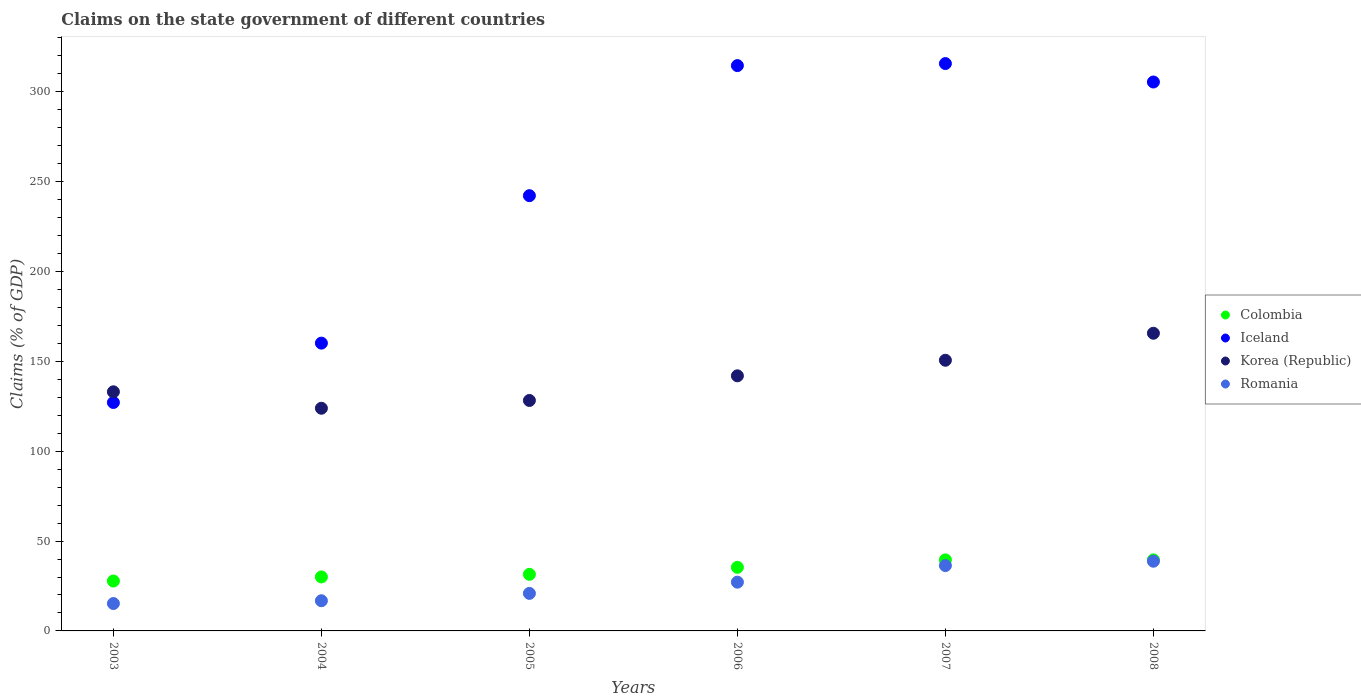Is the number of dotlines equal to the number of legend labels?
Offer a very short reply. Yes. What is the percentage of GDP claimed on the state government in Colombia in 2004?
Your answer should be compact. 30.04. Across all years, what is the maximum percentage of GDP claimed on the state government in Romania?
Make the answer very short. 38.78. Across all years, what is the minimum percentage of GDP claimed on the state government in Romania?
Offer a terse response. 15.24. What is the total percentage of GDP claimed on the state government in Colombia in the graph?
Give a very brief answer. 203.73. What is the difference between the percentage of GDP claimed on the state government in Colombia in 2004 and that in 2007?
Provide a succinct answer. -9.48. What is the difference between the percentage of GDP claimed on the state government in Romania in 2003 and the percentage of GDP claimed on the state government in Iceland in 2008?
Give a very brief answer. -290.18. What is the average percentage of GDP claimed on the state government in Korea (Republic) per year?
Your answer should be compact. 140.56. In the year 2006, what is the difference between the percentage of GDP claimed on the state government in Iceland and percentage of GDP claimed on the state government in Romania?
Your response must be concise. 287.42. What is the ratio of the percentage of GDP claimed on the state government in Iceland in 2004 to that in 2008?
Keep it short and to the point. 0.52. Is the percentage of GDP claimed on the state government in Iceland in 2005 less than that in 2008?
Keep it short and to the point. Yes. Is the difference between the percentage of GDP claimed on the state government in Iceland in 2004 and 2005 greater than the difference between the percentage of GDP claimed on the state government in Romania in 2004 and 2005?
Offer a terse response. No. What is the difference between the highest and the second highest percentage of GDP claimed on the state government in Romania?
Offer a terse response. 2.44. What is the difference between the highest and the lowest percentage of GDP claimed on the state government in Iceland?
Give a very brief answer. 188.58. Is it the case that in every year, the sum of the percentage of GDP claimed on the state government in Romania and percentage of GDP claimed on the state government in Iceland  is greater than the sum of percentage of GDP claimed on the state government in Korea (Republic) and percentage of GDP claimed on the state government in Colombia?
Your response must be concise. Yes. Is it the case that in every year, the sum of the percentage of GDP claimed on the state government in Colombia and percentage of GDP claimed on the state government in Romania  is greater than the percentage of GDP claimed on the state government in Korea (Republic)?
Ensure brevity in your answer.  No. Does the percentage of GDP claimed on the state government in Colombia monotonically increase over the years?
Your response must be concise. Yes. Is the percentage of GDP claimed on the state government in Korea (Republic) strictly less than the percentage of GDP claimed on the state government in Iceland over the years?
Make the answer very short. No. How many years are there in the graph?
Offer a very short reply. 6. Does the graph contain any zero values?
Give a very brief answer. No. Where does the legend appear in the graph?
Your answer should be very brief. Center right. How are the legend labels stacked?
Provide a succinct answer. Vertical. What is the title of the graph?
Offer a very short reply. Claims on the state government of different countries. Does "Kuwait" appear as one of the legend labels in the graph?
Offer a very short reply. No. What is the label or title of the Y-axis?
Your answer should be very brief. Claims (% of GDP). What is the Claims (% of GDP) of Colombia in 2003?
Provide a short and direct response. 27.76. What is the Claims (% of GDP) of Iceland in 2003?
Your response must be concise. 127.1. What is the Claims (% of GDP) in Korea (Republic) in 2003?
Provide a succinct answer. 133.05. What is the Claims (% of GDP) in Romania in 2003?
Give a very brief answer. 15.24. What is the Claims (% of GDP) of Colombia in 2004?
Ensure brevity in your answer.  30.04. What is the Claims (% of GDP) of Iceland in 2004?
Offer a terse response. 160.13. What is the Claims (% of GDP) in Korea (Republic) in 2004?
Ensure brevity in your answer.  123.89. What is the Claims (% of GDP) of Romania in 2004?
Your response must be concise. 16.79. What is the Claims (% of GDP) of Colombia in 2005?
Keep it short and to the point. 31.48. What is the Claims (% of GDP) of Iceland in 2005?
Offer a very short reply. 242.18. What is the Claims (% of GDP) of Korea (Republic) in 2005?
Your answer should be compact. 128.22. What is the Claims (% of GDP) of Romania in 2005?
Offer a terse response. 20.89. What is the Claims (% of GDP) of Colombia in 2006?
Give a very brief answer. 35.38. What is the Claims (% of GDP) in Iceland in 2006?
Ensure brevity in your answer.  314.55. What is the Claims (% of GDP) of Korea (Republic) in 2006?
Ensure brevity in your answer.  141.94. What is the Claims (% of GDP) in Romania in 2006?
Your answer should be very brief. 27.13. What is the Claims (% of GDP) in Colombia in 2007?
Make the answer very short. 39.53. What is the Claims (% of GDP) of Iceland in 2007?
Your answer should be very brief. 315.68. What is the Claims (% of GDP) of Korea (Republic) in 2007?
Your answer should be very brief. 150.6. What is the Claims (% of GDP) of Romania in 2007?
Ensure brevity in your answer.  36.35. What is the Claims (% of GDP) of Colombia in 2008?
Your response must be concise. 39.53. What is the Claims (% of GDP) of Iceland in 2008?
Offer a very short reply. 305.42. What is the Claims (% of GDP) in Korea (Republic) in 2008?
Provide a succinct answer. 165.63. What is the Claims (% of GDP) in Romania in 2008?
Give a very brief answer. 38.78. Across all years, what is the maximum Claims (% of GDP) of Colombia?
Provide a succinct answer. 39.53. Across all years, what is the maximum Claims (% of GDP) in Iceland?
Offer a very short reply. 315.68. Across all years, what is the maximum Claims (% of GDP) of Korea (Republic)?
Give a very brief answer. 165.63. Across all years, what is the maximum Claims (% of GDP) of Romania?
Keep it short and to the point. 38.78. Across all years, what is the minimum Claims (% of GDP) of Colombia?
Your answer should be very brief. 27.76. Across all years, what is the minimum Claims (% of GDP) in Iceland?
Keep it short and to the point. 127.1. Across all years, what is the minimum Claims (% of GDP) in Korea (Republic)?
Provide a succinct answer. 123.89. Across all years, what is the minimum Claims (% of GDP) in Romania?
Offer a terse response. 15.24. What is the total Claims (% of GDP) of Colombia in the graph?
Keep it short and to the point. 203.73. What is the total Claims (% of GDP) of Iceland in the graph?
Keep it short and to the point. 1465.05. What is the total Claims (% of GDP) in Korea (Republic) in the graph?
Provide a succinct answer. 843.34. What is the total Claims (% of GDP) in Romania in the graph?
Make the answer very short. 155.18. What is the difference between the Claims (% of GDP) in Colombia in 2003 and that in 2004?
Ensure brevity in your answer.  -2.28. What is the difference between the Claims (% of GDP) in Iceland in 2003 and that in 2004?
Your answer should be compact. -33.03. What is the difference between the Claims (% of GDP) in Korea (Republic) in 2003 and that in 2004?
Your answer should be very brief. 9.15. What is the difference between the Claims (% of GDP) in Romania in 2003 and that in 2004?
Offer a terse response. -1.55. What is the difference between the Claims (% of GDP) in Colombia in 2003 and that in 2005?
Offer a very short reply. -3.72. What is the difference between the Claims (% of GDP) in Iceland in 2003 and that in 2005?
Provide a succinct answer. -115.08. What is the difference between the Claims (% of GDP) in Korea (Republic) in 2003 and that in 2005?
Give a very brief answer. 4.82. What is the difference between the Claims (% of GDP) of Romania in 2003 and that in 2005?
Your answer should be very brief. -5.65. What is the difference between the Claims (% of GDP) in Colombia in 2003 and that in 2006?
Ensure brevity in your answer.  -7.62. What is the difference between the Claims (% of GDP) of Iceland in 2003 and that in 2006?
Give a very brief answer. -187.45. What is the difference between the Claims (% of GDP) of Korea (Republic) in 2003 and that in 2006?
Provide a short and direct response. -8.89. What is the difference between the Claims (% of GDP) of Romania in 2003 and that in 2006?
Your response must be concise. -11.89. What is the difference between the Claims (% of GDP) of Colombia in 2003 and that in 2007?
Your response must be concise. -11.76. What is the difference between the Claims (% of GDP) of Iceland in 2003 and that in 2007?
Provide a short and direct response. -188.58. What is the difference between the Claims (% of GDP) of Korea (Republic) in 2003 and that in 2007?
Offer a very short reply. -17.55. What is the difference between the Claims (% of GDP) of Romania in 2003 and that in 2007?
Ensure brevity in your answer.  -21.11. What is the difference between the Claims (% of GDP) in Colombia in 2003 and that in 2008?
Your answer should be compact. -11.77. What is the difference between the Claims (% of GDP) of Iceland in 2003 and that in 2008?
Offer a very short reply. -178.32. What is the difference between the Claims (% of GDP) of Korea (Republic) in 2003 and that in 2008?
Keep it short and to the point. -32.58. What is the difference between the Claims (% of GDP) of Romania in 2003 and that in 2008?
Keep it short and to the point. -23.55. What is the difference between the Claims (% of GDP) in Colombia in 2004 and that in 2005?
Provide a short and direct response. -1.44. What is the difference between the Claims (% of GDP) of Iceland in 2004 and that in 2005?
Provide a short and direct response. -82.05. What is the difference between the Claims (% of GDP) in Korea (Republic) in 2004 and that in 2005?
Your answer should be very brief. -4.33. What is the difference between the Claims (% of GDP) of Romania in 2004 and that in 2005?
Your answer should be very brief. -4.1. What is the difference between the Claims (% of GDP) in Colombia in 2004 and that in 2006?
Offer a very short reply. -5.34. What is the difference between the Claims (% of GDP) in Iceland in 2004 and that in 2006?
Offer a terse response. -154.42. What is the difference between the Claims (% of GDP) of Korea (Republic) in 2004 and that in 2006?
Your answer should be compact. -18.05. What is the difference between the Claims (% of GDP) of Romania in 2004 and that in 2006?
Make the answer very short. -10.34. What is the difference between the Claims (% of GDP) in Colombia in 2004 and that in 2007?
Make the answer very short. -9.48. What is the difference between the Claims (% of GDP) in Iceland in 2004 and that in 2007?
Give a very brief answer. -155.55. What is the difference between the Claims (% of GDP) in Korea (Republic) in 2004 and that in 2007?
Your answer should be very brief. -26.71. What is the difference between the Claims (% of GDP) of Romania in 2004 and that in 2007?
Ensure brevity in your answer.  -19.56. What is the difference between the Claims (% of GDP) in Colombia in 2004 and that in 2008?
Ensure brevity in your answer.  -9.49. What is the difference between the Claims (% of GDP) in Iceland in 2004 and that in 2008?
Provide a succinct answer. -145.29. What is the difference between the Claims (% of GDP) of Korea (Republic) in 2004 and that in 2008?
Provide a succinct answer. -41.73. What is the difference between the Claims (% of GDP) of Romania in 2004 and that in 2008?
Your answer should be very brief. -22. What is the difference between the Claims (% of GDP) of Colombia in 2005 and that in 2006?
Provide a succinct answer. -3.9. What is the difference between the Claims (% of GDP) of Iceland in 2005 and that in 2006?
Your answer should be compact. -72.37. What is the difference between the Claims (% of GDP) in Korea (Republic) in 2005 and that in 2006?
Provide a short and direct response. -13.72. What is the difference between the Claims (% of GDP) in Romania in 2005 and that in 2006?
Give a very brief answer. -6.25. What is the difference between the Claims (% of GDP) in Colombia in 2005 and that in 2007?
Your response must be concise. -8.04. What is the difference between the Claims (% of GDP) in Iceland in 2005 and that in 2007?
Your answer should be very brief. -73.5. What is the difference between the Claims (% of GDP) in Korea (Republic) in 2005 and that in 2007?
Ensure brevity in your answer.  -22.38. What is the difference between the Claims (% of GDP) of Romania in 2005 and that in 2007?
Provide a short and direct response. -15.46. What is the difference between the Claims (% of GDP) in Colombia in 2005 and that in 2008?
Offer a terse response. -8.05. What is the difference between the Claims (% of GDP) of Iceland in 2005 and that in 2008?
Make the answer very short. -63.24. What is the difference between the Claims (% of GDP) of Korea (Republic) in 2005 and that in 2008?
Ensure brevity in your answer.  -37.4. What is the difference between the Claims (% of GDP) in Romania in 2005 and that in 2008?
Provide a short and direct response. -17.9. What is the difference between the Claims (% of GDP) of Colombia in 2006 and that in 2007?
Keep it short and to the point. -4.14. What is the difference between the Claims (% of GDP) of Iceland in 2006 and that in 2007?
Give a very brief answer. -1.13. What is the difference between the Claims (% of GDP) in Korea (Republic) in 2006 and that in 2007?
Keep it short and to the point. -8.66. What is the difference between the Claims (% of GDP) of Romania in 2006 and that in 2007?
Provide a short and direct response. -9.21. What is the difference between the Claims (% of GDP) of Colombia in 2006 and that in 2008?
Your answer should be compact. -4.15. What is the difference between the Claims (% of GDP) of Iceland in 2006 and that in 2008?
Keep it short and to the point. 9.13. What is the difference between the Claims (% of GDP) of Korea (Republic) in 2006 and that in 2008?
Provide a succinct answer. -23.69. What is the difference between the Claims (% of GDP) of Romania in 2006 and that in 2008?
Keep it short and to the point. -11.65. What is the difference between the Claims (% of GDP) in Colombia in 2007 and that in 2008?
Ensure brevity in your answer.  -0.01. What is the difference between the Claims (% of GDP) in Iceland in 2007 and that in 2008?
Your answer should be compact. 10.26. What is the difference between the Claims (% of GDP) of Korea (Republic) in 2007 and that in 2008?
Provide a short and direct response. -15.03. What is the difference between the Claims (% of GDP) in Romania in 2007 and that in 2008?
Your response must be concise. -2.44. What is the difference between the Claims (% of GDP) in Colombia in 2003 and the Claims (% of GDP) in Iceland in 2004?
Offer a terse response. -132.37. What is the difference between the Claims (% of GDP) in Colombia in 2003 and the Claims (% of GDP) in Korea (Republic) in 2004?
Keep it short and to the point. -96.13. What is the difference between the Claims (% of GDP) in Colombia in 2003 and the Claims (% of GDP) in Romania in 2004?
Your answer should be compact. 10.97. What is the difference between the Claims (% of GDP) in Iceland in 2003 and the Claims (% of GDP) in Korea (Republic) in 2004?
Offer a terse response. 3.21. What is the difference between the Claims (% of GDP) in Iceland in 2003 and the Claims (% of GDP) in Romania in 2004?
Give a very brief answer. 110.31. What is the difference between the Claims (% of GDP) of Korea (Republic) in 2003 and the Claims (% of GDP) of Romania in 2004?
Your answer should be very brief. 116.26. What is the difference between the Claims (% of GDP) in Colombia in 2003 and the Claims (% of GDP) in Iceland in 2005?
Provide a short and direct response. -214.41. What is the difference between the Claims (% of GDP) in Colombia in 2003 and the Claims (% of GDP) in Korea (Republic) in 2005?
Offer a terse response. -100.46. What is the difference between the Claims (% of GDP) of Colombia in 2003 and the Claims (% of GDP) of Romania in 2005?
Keep it short and to the point. 6.88. What is the difference between the Claims (% of GDP) in Iceland in 2003 and the Claims (% of GDP) in Korea (Republic) in 2005?
Give a very brief answer. -1.12. What is the difference between the Claims (% of GDP) in Iceland in 2003 and the Claims (% of GDP) in Romania in 2005?
Your response must be concise. 106.21. What is the difference between the Claims (% of GDP) in Korea (Republic) in 2003 and the Claims (% of GDP) in Romania in 2005?
Keep it short and to the point. 112.16. What is the difference between the Claims (% of GDP) of Colombia in 2003 and the Claims (% of GDP) of Iceland in 2006?
Provide a succinct answer. -286.78. What is the difference between the Claims (% of GDP) of Colombia in 2003 and the Claims (% of GDP) of Korea (Republic) in 2006?
Give a very brief answer. -114.18. What is the difference between the Claims (% of GDP) of Colombia in 2003 and the Claims (% of GDP) of Romania in 2006?
Ensure brevity in your answer.  0.63. What is the difference between the Claims (% of GDP) of Iceland in 2003 and the Claims (% of GDP) of Korea (Republic) in 2006?
Offer a terse response. -14.84. What is the difference between the Claims (% of GDP) of Iceland in 2003 and the Claims (% of GDP) of Romania in 2006?
Provide a succinct answer. 99.97. What is the difference between the Claims (% of GDP) in Korea (Republic) in 2003 and the Claims (% of GDP) in Romania in 2006?
Your answer should be compact. 105.92. What is the difference between the Claims (% of GDP) in Colombia in 2003 and the Claims (% of GDP) in Iceland in 2007?
Keep it short and to the point. -287.91. What is the difference between the Claims (% of GDP) in Colombia in 2003 and the Claims (% of GDP) in Korea (Republic) in 2007?
Give a very brief answer. -122.84. What is the difference between the Claims (% of GDP) of Colombia in 2003 and the Claims (% of GDP) of Romania in 2007?
Give a very brief answer. -8.58. What is the difference between the Claims (% of GDP) in Iceland in 2003 and the Claims (% of GDP) in Korea (Republic) in 2007?
Your answer should be very brief. -23.5. What is the difference between the Claims (% of GDP) in Iceland in 2003 and the Claims (% of GDP) in Romania in 2007?
Your response must be concise. 90.75. What is the difference between the Claims (% of GDP) of Korea (Republic) in 2003 and the Claims (% of GDP) of Romania in 2007?
Ensure brevity in your answer.  96.7. What is the difference between the Claims (% of GDP) of Colombia in 2003 and the Claims (% of GDP) of Iceland in 2008?
Provide a short and direct response. -277.66. What is the difference between the Claims (% of GDP) in Colombia in 2003 and the Claims (% of GDP) in Korea (Republic) in 2008?
Keep it short and to the point. -137.86. What is the difference between the Claims (% of GDP) of Colombia in 2003 and the Claims (% of GDP) of Romania in 2008?
Your answer should be very brief. -11.02. What is the difference between the Claims (% of GDP) in Iceland in 2003 and the Claims (% of GDP) in Korea (Republic) in 2008?
Offer a terse response. -38.53. What is the difference between the Claims (% of GDP) of Iceland in 2003 and the Claims (% of GDP) of Romania in 2008?
Your answer should be very brief. 88.32. What is the difference between the Claims (% of GDP) of Korea (Republic) in 2003 and the Claims (% of GDP) of Romania in 2008?
Your answer should be very brief. 94.26. What is the difference between the Claims (% of GDP) in Colombia in 2004 and the Claims (% of GDP) in Iceland in 2005?
Provide a short and direct response. -212.13. What is the difference between the Claims (% of GDP) in Colombia in 2004 and the Claims (% of GDP) in Korea (Republic) in 2005?
Your response must be concise. -98.18. What is the difference between the Claims (% of GDP) of Colombia in 2004 and the Claims (% of GDP) of Romania in 2005?
Offer a very short reply. 9.16. What is the difference between the Claims (% of GDP) of Iceland in 2004 and the Claims (% of GDP) of Korea (Republic) in 2005?
Offer a terse response. 31.9. What is the difference between the Claims (% of GDP) of Iceland in 2004 and the Claims (% of GDP) of Romania in 2005?
Ensure brevity in your answer.  139.24. What is the difference between the Claims (% of GDP) of Korea (Republic) in 2004 and the Claims (% of GDP) of Romania in 2005?
Ensure brevity in your answer.  103.01. What is the difference between the Claims (% of GDP) of Colombia in 2004 and the Claims (% of GDP) of Iceland in 2006?
Keep it short and to the point. -284.51. What is the difference between the Claims (% of GDP) in Colombia in 2004 and the Claims (% of GDP) in Korea (Republic) in 2006?
Your response must be concise. -111.9. What is the difference between the Claims (% of GDP) in Colombia in 2004 and the Claims (% of GDP) in Romania in 2006?
Make the answer very short. 2.91. What is the difference between the Claims (% of GDP) of Iceland in 2004 and the Claims (% of GDP) of Korea (Republic) in 2006?
Your answer should be very brief. 18.19. What is the difference between the Claims (% of GDP) in Iceland in 2004 and the Claims (% of GDP) in Romania in 2006?
Offer a terse response. 133. What is the difference between the Claims (% of GDP) in Korea (Republic) in 2004 and the Claims (% of GDP) in Romania in 2006?
Your answer should be compact. 96.76. What is the difference between the Claims (% of GDP) in Colombia in 2004 and the Claims (% of GDP) in Iceland in 2007?
Your response must be concise. -285.63. What is the difference between the Claims (% of GDP) of Colombia in 2004 and the Claims (% of GDP) of Korea (Republic) in 2007?
Provide a short and direct response. -120.56. What is the difference between the Claims (% of GDP) of Colombia in 2004 and the Claims (% of GDP) of Romania in 2007?
Provide a short and direct response. -6.3. What is the difference between the Claims (% of GDP) of Iceland in 2004 and the Claims (% of GDP) of Korea (Republic) in 2007?
Your response must be concise. 9.53. What is the difference between the Claims (% of GDP) of Iceland in 2004 and the Claims (% of GDP) of Romania in 2007?
Offer a terse response. 123.78. What is the difference between the Claims (% of GDP) of Korea (Republic) in 2004 and the Claims (% of GDP) of Romania in 2007?
Your response must be concise. 87.55. What is the difference between the Claims (% of GDP) in Colombia in 2004 and the Claims (% of GDP) in Iceland in 2008?
Give a very brief answer. -275.38. What is the difference between the Claims (% of GDP) of Colombia in 2004 and the Claims (% of GDP) of Korea (Republic) in 2008?
Ensure brevity in your answer.  -135.58. What is the difference between the Claims (% of GDP) of Colombia in 2004 and the Claims (% of GDP) of Romania in 2008?
Make the answer very short. -8.74. What is the difference between the Claims (% of GDP) in Iceland in 2004 and the Claims (% of GDP) in Korea (Republic) in 2008?
Provide a succinct answer. -5.5. What is the difference between the Claims (% of GDP) of Iceland in 2004 and the Claims (% of GDP) of Romania in 2008?
Provide a short and direct response. 121.34. What is the difference between the Claims (% of GDP) in Korea (Republic) in 2004 and the Claims (% of GDP) in Romania in 2008?
Offer a terse response. 85.11. What is the difference between the Claims (% of GDP) in Colombia in 2005 and the Claims (% of GDP) in Iceland in 2006?
Your answer should be compact. -283.06. What is the difference between the Claims (% of GDP) of Colombia in 2005 and the Claims (% of GDP) of Korea (Republic) in 2006?
Offer a very short reply. -110.46. What is the difference between the Claims (% of GDP) in Colombia in 2005 and the Claims (% of GDP) in Romania in 2006?
Your answer should be compact. 4.35. What is the difference between the Claims (% of GDP) in Iceland in 2005 and the Claims (% of GDP) in Korea (Republic) in 2006?
Ensure brevity in your answer.  100.24. What is the difference between the Claims (% of GDP) in Iceland in 2005 and the Claims (% of GDP) in Romania in 2006?
Give a very brief answer. 215.04. What is the difference between the Claims (% of GDP) of Korea (Republic) in 2005 and the Claims (% of GDP) of Romania in 2006?
Make the answer very short. 101.09. What is the difference between the Claims (% of GDP) of Colombia in 2005 and the Claims (% of GDP) of Iceland in 2007?
Keep it short and to the point. -284.19. What is the difference between the Claims (% of GDP) in Colombia in 2005 and the Claims (% of GDP) in Korea (Republic) in 2007?
Your answer should be compact. -119.12. What is the difference between the Claims (% of GDP) of Colombia in 2005 and the Claims (% of GDP) of Romania in 2007?
Keep it short and to the point. -4.86. What is the difference between the Claims (% of GDP) in Iceland in 2005 and the Claims (% of GDP) in Korea (Republic) in 2007?
Your response must be concise. 91.58. What is the difference between the Claims (% of GDP) of Iceland in 2005 and the Claims (% of GDP) of Romania in 2007?
Your answer should be compact. 205.83. What is the difference between the Claims (% of GDP) in Korea (Republic) in 2005 and the Claims (% of GDP) in Romania in 2007?
Offer a terse response. 91.88. What is the difference between the Claims (% of GDP) of Colombia in 2005 and the Claims (% of GDP) of Iceland in 2008?
Your answer should be compact. -273.94. What is the difference between the Claims (% of GDP) of Colombia in 2005 and the Claims (% of GDP) of Korea (Republic) in 2008?
Ensure brevity in your answer.  -134.14. What is the difference between the Claims (% of GDP) in Colombia in 2005 and the Claims (% of GDP) in Romania in 2008?
Provide a succinct answer. -7.3. What is the difference between the Claims (% of GDP) in Iceland in 2005 and the Claims (% of GDP) in Korea (Republic) in 2008?
Your answer should be compact. 76.55. What is the difference between the Claims (% of GDP) in Iceland in 2005 and the Claims (% of GDP) in Romania in 2008?
Your answer should be compact. 203.39. What is the difference between the Claims (% of GDP) in Korea (Republic) in 2005 and the Claims (% of GDP) in Romania in 2008?
Your answer should be very brief. 89.44. What is the difference between the Claims (% of GDP) in Colombia in 2006 and the Claims (% of GDP) in Iceland in 2007?
Offer a very short reply. -280.29. What is the difference between the Claims (% of GDP) of Colombia in 2006 and the Claims (% of GDP) of Korea (Republic) in 2007?
Give a very brief answer. -115.21. What is the difference between the Claims (% of GDP) of Colombia in 2006 and the Claims (% of GDP) of Romania in 2007?
Ensure brevity in your answer.  -0.96. What is the difference between the Claims (% of GDP) in Iceland in 2006 and the Claims (% of GDP) in Korea (Republic) in 2007?
Provide a short and direct response. 163.95. What is the difference between the Claims (% of GDP) of Iceland in 2006 and the Claims (% of GDP) of Romania in 2007?
Your answer should be compact. 278.2. What is the difference between the Claims (% of GDP) of Korea (Republic) in 2006 and the Claims (% of GDP) of Romania in 2007?
Offer a terse response. 105.59. What is the difference between the Claims (% of GDP) in Colombia in 2006 and the Claims (% of GDP) in Iceland in 2008?
Offer a very short reply. -270.03. What is the difference between the Claims (% of GDP) of Colombia in 2006 and the Claims (% of GDP) of Korea (Republic) in 2008?
Provide a succinct answer. -130.24. What is the difference between the Claims (% of GDP) of Colombia in 2006 and the Claims (% of GDP) of Romania in 2008?
Your answer should be compact. -3.4. What is the difference between the Claims (% of GDP) in Iceland in 2006 and the Claims (% of GDP) in Korea (Republic) in 2008?
Provide a short and direct response. 148.92. What is the difference between the Claims (% of GDP) in Iceland in 2006 and the Claims (% of GDP) in Romania in 2008?
Make the answer very short. 275.76. What is the difference between the Claims (% of GDP) in Korea (Republic) in 2006 and the Claims (% of GDP) in Romania in 2008?
Offer a terse response. 103.16. What is the difference between the Claims (% of GDP) of Colombia in 2007 and the Claims (% of GDP) of Iceland in 2008?
Keep it short and to the point. -265.89. What is the difference between the Claims (% of GDP) in Colombia in 2007 and the Claims (% of GDP) in Korea (Republic) in 2008?
Your answer should be very brief. -126.1. What is the difference between the Claims (% of GDP) in Colombia in 2007 and the Claims (% of GDP) in Romania in 2008?
Your answer should be very brief. 0.74. What is the difference between the Claims (% of GDP) in Iceland in 2007 and the Claims (% of GDP) in Korea (Republic) in 2008?
Offer a terse response. 150.05. What is the difference between the Claims (% of GDP) in Iceland in 2007 and the Claims (% of GDP) in Romania in 2008?
Ensure brevity in your answer.  276.89. What is the difference between the Claims (% of GDP) in Korea (Republic) in 2007 and the Claims (% of GDP) in Romania in 2008?
Offer a very short reply. 111.82. What is the average Claims (% of GDP) of Colombia per year?
Give a very brief answer. 33.96. What is the average Claims (% of GDP) in Iceland per year?
Make the answer very short. 244.17. What is the average Claims (% of GDP) in Korea (Republic) per year?
Your answer should be very brief. 140.56. What is the average Claims (% of GDP) in Romania per year?
Provide a short and direct response. 25.86. In the year 2003, what is the difference between the Claims (% of GDP) in Colombia and Claims (% of GDP) in Iceland?
Keep it short and to the point. -99.34. In the year 2003, what is the difference between the Claims (% of GDP) in Colombia and Claims (% of GDP) in Korea (Republic)?
Offer a very short reply. -105.28. In the year 2003, what is the difference between the Claims (% of GDP) in Colombia and Claims (% of GDP) in Romania?
Keep it short and to the point. 12.53. In the year 2003, what is the difference between the Claims (% of GDP) of Iceland and Claims (% of GDP) of Korea (Republic)?
Ensure brevity in your answer.  -5.95. In the year 2003, what is the difference between the Claims (% of GDP) of Iceland and Claims (% of GDP) of Romania?
Give a very brief answer. 111.86. In the year 2003, what is the difference between the Claims (% of GDP) in Korea (Republic) and Claims (% of GDP) in Romania?
Offer a terse response. 117.81. In the year 2004, what is the difference between the Claims (% of GDP) in Colombia and Claims (% of GDP) in Iceland?
Ensure brevity in your answer.  -130.09. In the year 2004, what is the difference between the Claims (% of GDP) in Colombia and Claims (% of GDP) in Korea (Republic)?
Your answer should be very brief. -93.85. In the year 2004, what is the difference between the Claims (% of GDP) of Colombia and Claims (% of GDP) of Romania?
Your answer should be very brief. 13.25. In the year 2004, what is the difference between the Claims (% of GDP) of Iceland and Claims (% of GDP) of Korea (Republic)?
Ensure brevity in your answer.  36.23. In the year 2004, what is the difference between the Claims (% of GDP) in Iceland and Claims (% of GDP) in Romania?
Make the answer very short. 143.34. In the year 2004, what is the difference between the Claims (% of GDP) of Korea (Republic) and Claims (% of GDP) of Romania?
Keep it short and to the point. 107.11. In the year 2005, what is the difference between the Claims (% of GDP) of Colombia and Claims (% of GDP) of Iceland?
Your answer should be compact. -210.69. In the year 2005, what is the difference between the Claims (% of GDP) in Colombia and Claims (% of GDP) in Korea (Republic)?
Your response must be concise. -96.74. In the year 2005, what is the difference between the Claims (% of GDP) in Colombia and Claims (% of GDP) in Romania?
Your response must be concise. 10.6. In the year 2005, what is the difference between the Claims (% of GDP) in Iceland and Claims (% of GDP) in Korea (Republic)?
Ensure brevity in your answer.  113.95. In the year 2005, what is the difference between the Claims (% of GDP) in Iceland and Claims (% of GDP) in Romania?
Give a very brief answer. 221.29. In the year 2005, what is the difference between the Claims (% of GDP) of Korea (Republic) and Claims (% of GDP) of Romania?
Keep it short and to the point. 107.34. In the year 2006, what is the difference between the Claims (% of GDP) of Colombia and Claims (% of GDP) of Iceland?
Give a very brief answer. -279.16. In the year 2006, what is the difference between the Claims (% of GDP) in Colombia and Claims (% of GDP) in Korea (Republic)?
Provide a short and direct response. -106.56. In the year 2006, what is the difference between the Claims (% of GDP) in Colombia and Claims (% of GDP) in Romania?
Provide a short and direct response. 8.25. In the year 2006, what is the difference between the Claims (% of GDP) in Iceland and Claims (% of GDP) in Korea (Republic)?
Keep it short and to the point. 172.61. In the year 2006, what is the difference between the Claims (% of GDP) of Iceland and Claims (% of GDP) of Romania?
Make the answer very short. 287.42. In the year 2006, what is the difference between the Claims (% of GDP) of Korea (Republic) and Claims (% of GDP) of Romania?
Ensure brevity in your answer.  114.81. In the year 2007, what is the difference between the Claims (% of GDP) of Colombia and Claims (% of GDP) of Iceland?
Provide a succinct answer. -276.15. In the year 2007, what is the difference between the Claims (% of GDP) of Colombia and Claims (% of GDP) of Korea (Republic)?
Make the answer very short. -111.07. In the year 2007, what is the difference between the Claims (% of GDP) of Colombia and Claims (% of GDP) of Romania?
Keep it short and to the point. 3.18. In the year 2007, what is the difference between the Claims (% of GDP) of Iceland and Claims (% of GDP) of Korea (Republic)?
Your answer should be compact. 165.08. In the year 2007, what is the difference between the Claims (% of GDP) in Iceland and Claims (% of GDP) in Romania?
Give a very brief answer. 279.33. In the year 2007, what is the difference between the Claims (% of GDP) of Korea (Republic) and Claims (% of GDP) of Romania?
Your answer should be very brief. 114.25. In the year 2008, what is the difference between the Claims (% of GDP) of Colombia and Claims (% of GDP) of Iceland?
Your answer should be compact. -265.89. In the year 2008, what is the difference between the Claims (% of GDP) of Colombia and Claims (% of GDP) of Korea (Republic)?
Keep it short and to the point. -126.1. In the year 2008, what is the difference between the Claims (% of GDP) of Colombia and Claims (% of GDP) of Romania?
Your answer should be very brief. 0.75. In the year 2008, what is the difference between the Claims (% of GDP) of Iceland and Claims (% of GDP) of Korea (Republic)?
Your response must be concise. 139.79. In the year 2008, what is the difference between the Claims (% of GDP) of Iceland and Claims (% of GDP) of Romania?
Your answer should be compact. 266.63. In the year 2008, what is the difference between the Claims (% of GDP) in Korea (Republic) and Claims (% of GDP) in Romania?
Give a very brief answer. 126.84. What is the ratio of the Claims (% of GDP) of Colombia in 2003 to that in 2004?
Provide a short and direct response. 0.92. What is the ratio of the Claims (% of GDP) in Iceland in 2003 to that in 2004?
Provide a short and direct response. 0.79. What is the ratio of the Claims (% of GDP) in Korea (Republic) in 2003 to that in 2004?
Ensure brevity in your answer.  1.07. What is the ratio of the Claims (% of GDP) of Romania in 2003 to that in 2004?
Offer a very short reply. 0.91. What is the ratio of the Claims (% of GDP) of Colombia in 2003 to that in 2005?
Your response must be concise. 0.88. What is the ratio of the Claims (% of GDP) of Iceland in 2003 to that in 2005?
Give a very brief answer. 0.52. What is the ratio of the Claims (% of GDP) in Korea (Republic) in 2003 to that in 2005?
Your answer should be compact. 1.04. What is the ratio of the Claims (% of GDP) of Romania in 2003 to that in 2005?
Ensure brevity in your answer.  0.73. What is the ratio of the Claims (% of GDP) in Colombia in 2003 to that in 2006?
Offer a terse response. 0.78. What is the ratio of the Claims (% of GDP) in Iceland in 2003 to that in 2006?
Offer a very short reply. 0.4. What is the ratio of the Claims (% of GDP) of Korea (Republic) in 2003 to that in 2006?
Provide a succinct answer. 0.94. What is the ratio of the Claims (% of GDP) of Romania in 2003 to that in 2006?
Ensure brevity in your answer.  0.56. What is the ratio of the Claims (% of GDP) of Colombia in 2003 to that in 2007?
Make the answer very short. 0.7. What is the ratio of the Claims (% of GDP) in Iceland in 2003 to that in 2007?
Your answer should be very brief. 0.4. What is the ratio of the Claims (% of GDP) of Korea (Republic) in 2003 to that in 2007?
Your answer should be compact. 0.88. What is the ratio of the Claims (% of GDP) in Romania in 2003 to that in 2007?
Make the answer very short. 0.42. What is the ratio of the Claims (% of GDP) in Colombia in 2003 to that in 2008?
Offer a terse response. 0.7. What is the ratio of the Claims (% of GDP) in Iceland in 2003 to that in 2008?
Your answer should be very brief. 0.42. What is the ratio of the Claims (% of GDP) of Korea (Republic) in 2003 to that in 2008?
Offer a terse response. 0.8. What is the ratio of the Claims (% of GDP) of Romania in 2003 to that in 2008?
Your answer should be very brief. 0.39. What is the ratio of the Claims (% of GDP) of Colombia in 2004 to that in 2005?
Offer a very short reply. 0.95. What is the ratio of the Claims (% of GDP) of Iceland in 2004 to that in 2005?
Provide a short and direct response. 0.66. What is the ratio of the Claims (% of GDP) of Korea (Republic) in 2004 to that in 2005?
Give a very brief answer. 0.97. What is the ratio of the Claims (% of GDP) in Romania in 2004 to that in 2005?
Give a very brief answer. 0.8. What is the ratio of the Claims (% of GDP) in Colombia in 2004 to that in 2006?
Provide a succinct answer. 0.85. What is the ratio of the Claims (% of GDP) of Iceland in 2004 to that in 2006?
Ensure brevity in your answer.  0.51. What is the ratio of the Claims (% of GDP) in Korea (Republic) in 2004 to that in 2006?
Give a very brief answer. 0.87. What is the ratio of the Claims (% of GDP) of Romania in 2004 to that in 2006?
Make the answer very short. 0.62. What is the ratio of the Claims (% of GDP) in Colombia in 2004 to that in 2007?
Provide a short and direct response. 0.76. What is the ratio of the Claims (% of GDP) of Iceland in 2004 to that in 2007?
Make the answer very short. 0.51. What is the ratio of the Claims (% of GDP) in Korea (Republic) in 2004 to that in 2007?
Your response must be concise. 0.82. What is the ratio of the Claims (% of GDP) in Romania in 2004 to that in 2007?
Offer a very short reply. 0.46. What is the ratio of the Claims (% of GDP) in Colombia in 2004 to that in 2008?
Make the answer very short. 0.76. What is the ratio of the Claims (% of GDP) in Iceland in 2004 to that in 2008?
Offer a very short reply. 0.52. What is the ratio of the Claims (% of GDP) in Korea (Republic) in 2004 to that in 2008?
Your answer should be very brief. 0.75. What is the ratio of the Claims (% of GDP) in Romania in 2004 to that in 2008?
Your answer should be very brief. 0.43. What is the ratio of the Claims (% of GDP) in Colombia in 2005 to that in 2006?
Ensure brevity in your answer.  0.89. What is the ratio of the Claims (% of GDP) in Iceland in 2005 to that in 2006?
Offer a very short reply. 0.77. What is the ratio of the Claims (% of GDP) of Korea (Republic) in 2005 to that in 2006?
Your answer should be very brief. 0.9. What is the ratio of the Claims (% of GDP) in Romania in 2005 to that in 2006?
Ensure brevity in your answer.  0.77. What is the ratio of the Claims (% of GDP) in Colombia in 2005 to that in 2007?
Offer a terse response. 0.8. What is the ratio of the Claims (% of GDP) of Iceland in 2005 to that in 2007?
Provide a short and direct response. 0.77. What is the ratio of the Claims (% of GDP) in Korea (Republic) in 2005 to that in 2007?
Provide a short and direct response. 0.85. What is the ratio of the Claims (% of GDP) in Romania in 2005 to that in 2007?
Provide a succinct answer. 0.57. What is the ratio of the Claims (% of GDP) in Colombia in 2005 to that in 2008?
Give a very brief answer. 0.8. What is the ratio of the Claims (% of GDP) of Iceland in 2005 to that in 2008?
Keep it short and to the point. 0.79. What is the ratio of the Claims (% of GDP) of Korea (Republic) in 2005 to that in 2008?
Offer a very short reply. 0.77. What is the ratio of the Claims (% of GDP) of Romania in 2005 to that in 2008?
Offer a very short reply. 0.54. What is the ratio of the Claims (% of GDP) of Colombia in 2006 to that in 2007?
Make the answer very short. 0.9. What is the ratio of the Claims (% of GDP) of Iceland in 2006 to that in 2007?
Make the answer very short. 1. What is the ratio of the Claims (% of GDP) in Korea (Republic) in 2006 to that in 2007?
Give a very brief answer. 0.94. What is the ratio of the Claims (% of GDP) of Romania in 2006 to that in 2007?
Make the answer very short. 0.75. What is the ratio of the Claims (% of GDP) in Colombia in 2006 to that in 2008?
Make the answer very short. 0.9. What is the ratio of the Claims (% of GDP) of Iceland in 2006 to that in 2008?
Keep it short and to the point. 1.03. What is the ratio of the Claims (% of GDP) in Korea (Republic) in 2006 to that in 2008?
Keep it short and to the point. 0.86. What is the ratio of the Claims (% of GDP) of Romania in 2006 to that in 2008?
Offer a terse response. 0.7. What is the ratio of the Claims (% of GDP) in Colombia in 2007 to that in 2008?
Offer a very short reply. 1. What is the ratio of the Claims (% of GDP) of Iceland in 2007 to that in 2008?
Make the answer very short. 1.03. What is the ratio of the Claims (% of GDP) of Korea (Republic) in 2007 to that in 2008?
Offer a terse response. 0.91. What is the ratio of the Claims (% of GDP) in Romania in 2007 to that in 2008?
Your response must be concise. 0.94. What is the difference between the highest and the second highest Claims (% of GDP) of Colombia?
Provide a short and direct response. 0.01. What is the difference between the highest and the second highest Claims (% of GDP) in Iceland?
Ensure brevity in your answer.  1.13. What is the difference between the highest and the second highest Claims (% of GDP) of Korea (Republic)?
Provide a short and direct response. 15.03. What is the difference between the highest and the second highest Claims (% of GDP) in Romania?
Provide a short and direct response. 2.44. What is the difference between the highest and the lowest Claims (% of GDP) of Colombia?
Your response must be concise. 11.77. What is the difference between the highest and the lowest Claims (% of GDP) in Iceland?
Provide a succinct answer. 188.58. What is the difference between the highest and the lowest Claims (% of GDP) in Korea (Republic)?
Your answer should be very brief. 41.73. What is the difference between the highest and the lowest Claims (% of GDP) of Romania?
Keep it short and to the point. 23.55. 